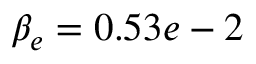Convert formula to latex. <formula><loc_0><loc_0><loc_500><loc_500>\beta _ { e } = 0 . 5 3 e - 2</formula> 